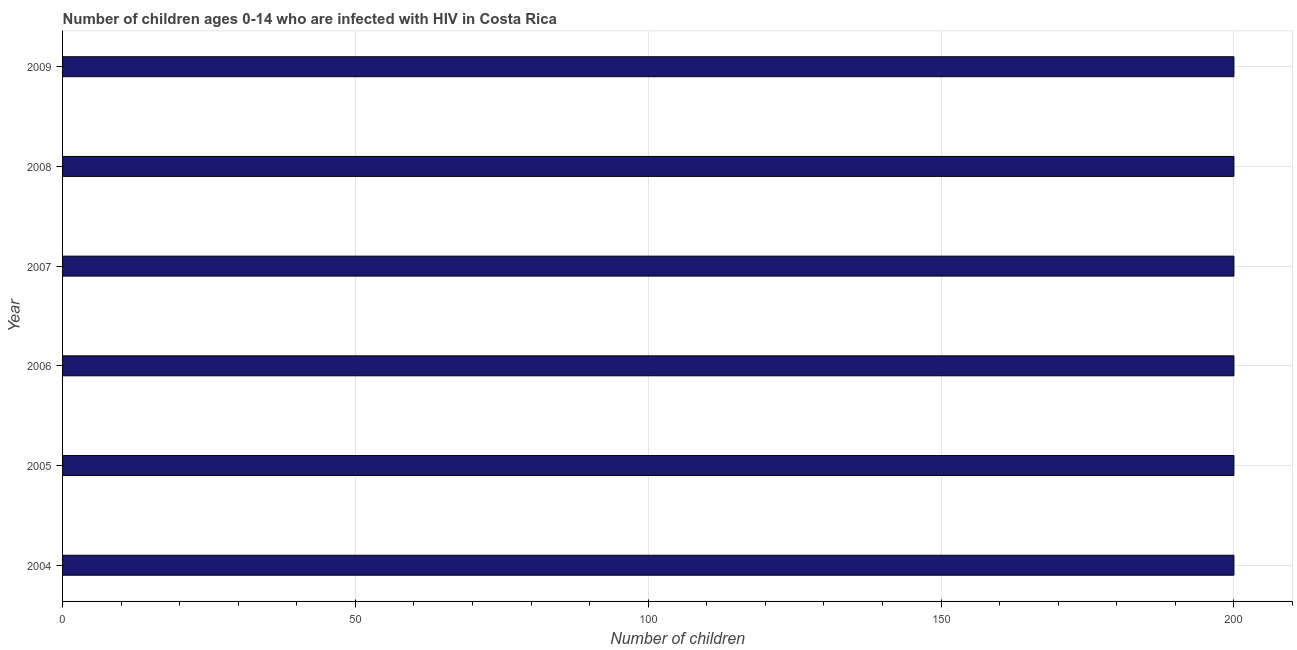What is the title of the graph?
Give a very brief answer. Number of children ages 0-14 who are infected with HIV in Costa Rica. What is the label or title of the X-axis?
Your answer should be compact. Number of children. Across all years, what is the minimum number of children living with hiv?
Your answer should be compact. 200. In which year was the number of children living with hiv minimum?
Keep it short and to the point. 2004. What is the sum of the number of children living with hiv?
Ensure brevity in your answer.  1200. What is the average number of children living with hiv per year?
Your response must be concise. 200. In how many years, is the number of children living with hiv greater than 10 ?
Your answer should be very brief. 6. Do a majority of the years between 2006 and 2005 (inclusive) have number of children living with hiv greater than 20 ?
Make the answer very short. No. What is the ratio of the number of children living with hiv in 2004 to that in 2009?
Keep it short and to the point. 1. Is the difference between the number of children living with hiv in 2004 and 2005 greater than the difference between any two years?
Ensure brevity in your answer.  Yes. Is the sum of the number of children living with hiv in 2004 and 2008 greater than the maximum number of children living with hiv across all years?
Keep it short and to the point. Yes. What is the difference between the highest and the lowest number of children living with hiv?
Make the answer very short. 0. How many years are there in the graph?
Offer a very short reply. 6. What is the difference between two consecutive major ticks on the X-axis?
Ensure brevity in your answer.  50. What is the Number of children of 2005?
Your response must be concise. 200. What is the Number of children in 2007?
Give a very brief answer. 200. What is the Number of children of 2009?
Provide a succinct answer. 200. What is the difference between the Number of children in 2004 and 2005?
Your answer should be compact. 0. What is the difference between the Number of children in 2004 and 2007?
Your answer should be very brief. 0. What is the difference between the Number of children in 2005 and 2008?
Offer a terse response. 0. What is the difference between the Number of children in 2005 and 2009?
Offer a very short reply. 0. What is the difference between the Number of children in 2006 and 2007?
Offer a terse response. 0. What is the difference between the Number of children in 2006 and 2008?
Make the answer very short. 0. What is the difference between the Number of children in 2006 and 2009?
Your response must be concise. 0. What is the difference between the Number of children in 2007 and 2009?
Provide a succinct answer. 0. What is the difference between the Number of children in 2008 and 2009?
Keep it short and to the point. 0. What is the ratio of the Number of children in 2004 to that in 2006?
Your answer should be compact. 1. What is the ratio of the Number of children in 2004 to that in 2007?
Your answer should be compact. 1. What is the ratio of the Number of children in 2004 to that in 2008?
Your answer should be very brief. 1. What is the ratio of the Number of children in 2005 to that in 2008?
Your response must be concise. 1. What is the ratio of the Number of children in 2005 to that in 2009?
Keep it short and to the point. 1. What is the ratio of the Number of children in 2007 to that in 2009?
Your answer should be very brief. 1. 